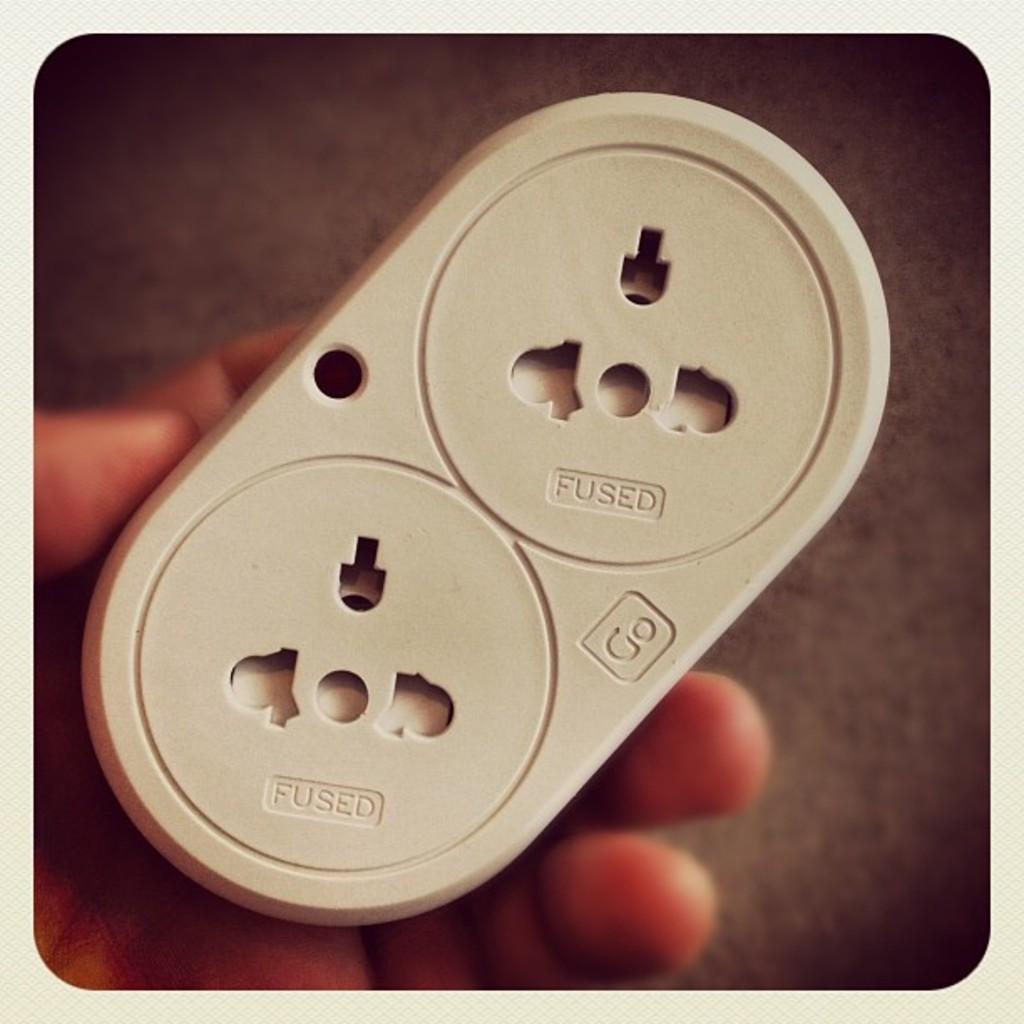What is special about this outlet?
Your response must be concise. Fused. What company produces this outlet?
Offer a terse response. Go. 